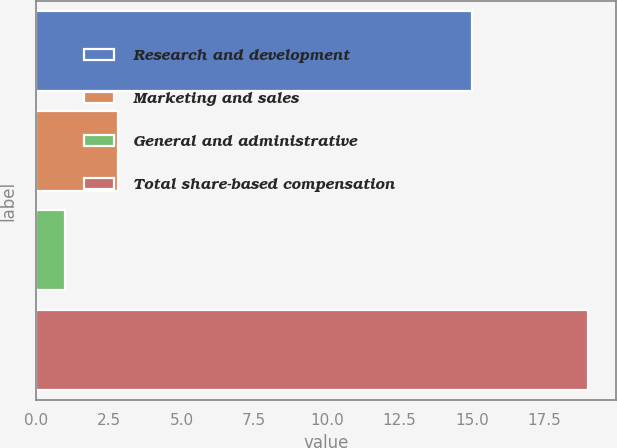Convert chart. <chart><loc_0><loc_0><loc_500><loc_500><bar_chart><fcel>Research and development<fcel>Marketing and sales<fcel>General and administrative<fcel>Total share-based compensation<nl><fcel>15<fcel>2.8<fcel>1<fcel>19<nl></chart> 